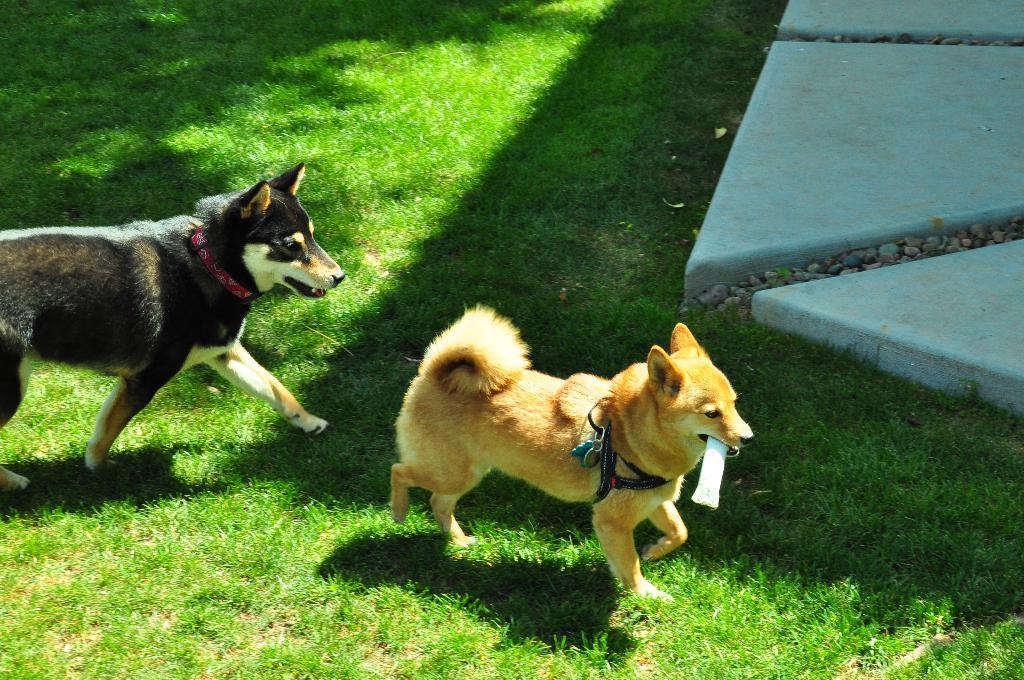Describe this image in one or two sentences. In this image we can see two dogs are walking on the ground and this dog is holding something in its mouth. Here we can see stones and marble ground. 